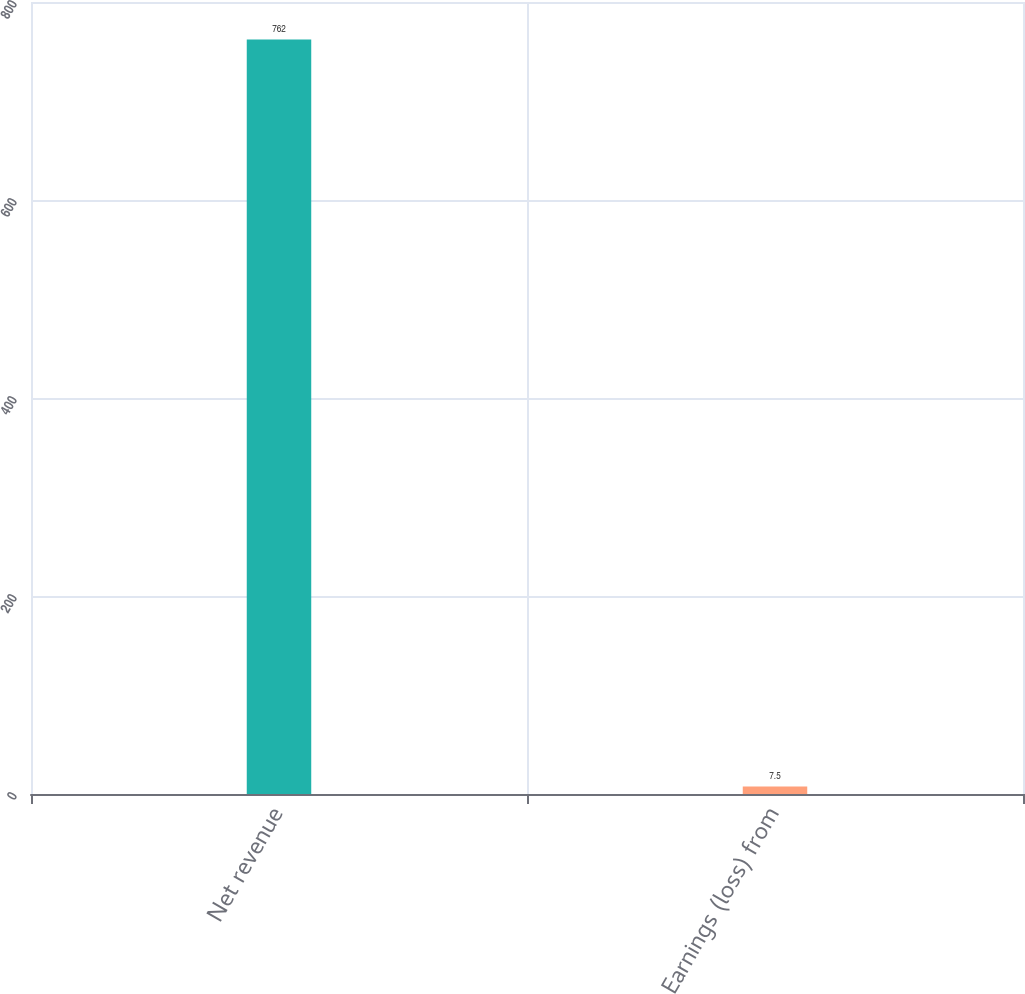Convert chart to OTSL. <chart><loc_0><loc_0><loc_500><loc_500><bar_chart><fcel>Net revenue<fcel>Earnings (loss) from<nl><fcel>762<fcel>7.5<nl></chart> 